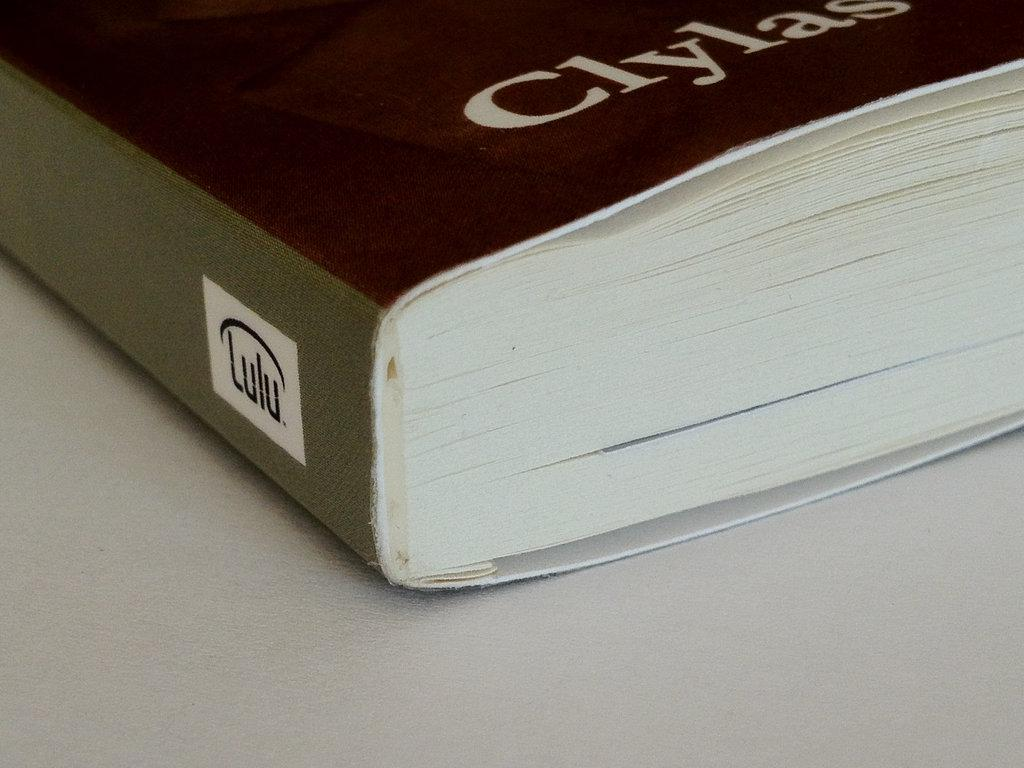<image>
Provide a brief description of the given image. A book has a Lulu logo on the binding. 